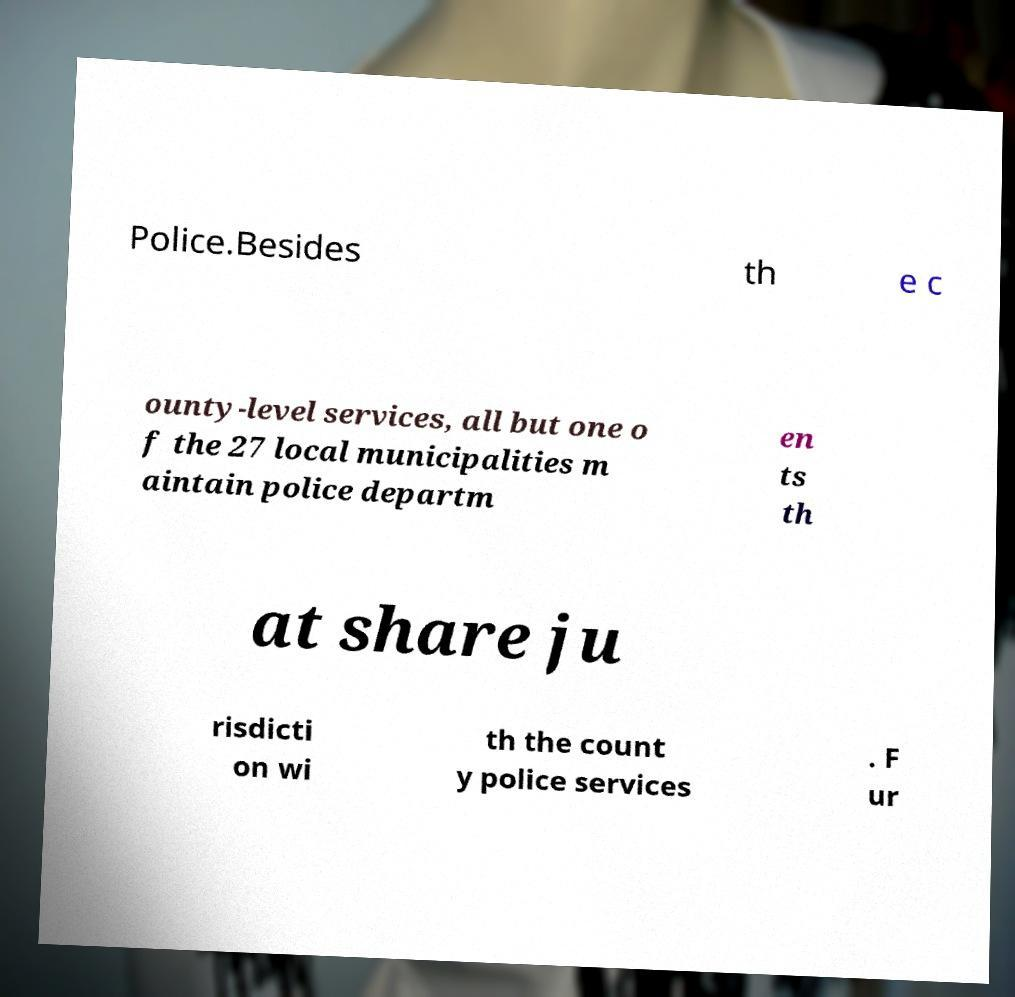Please read and relay the text visible in this image. What does it say? Police.Besides th e c ounty-level services, all but one o f the 27 local municipalities m aintain police departm en ts th at share ju risdicti on wi th the count y police services . F ur 